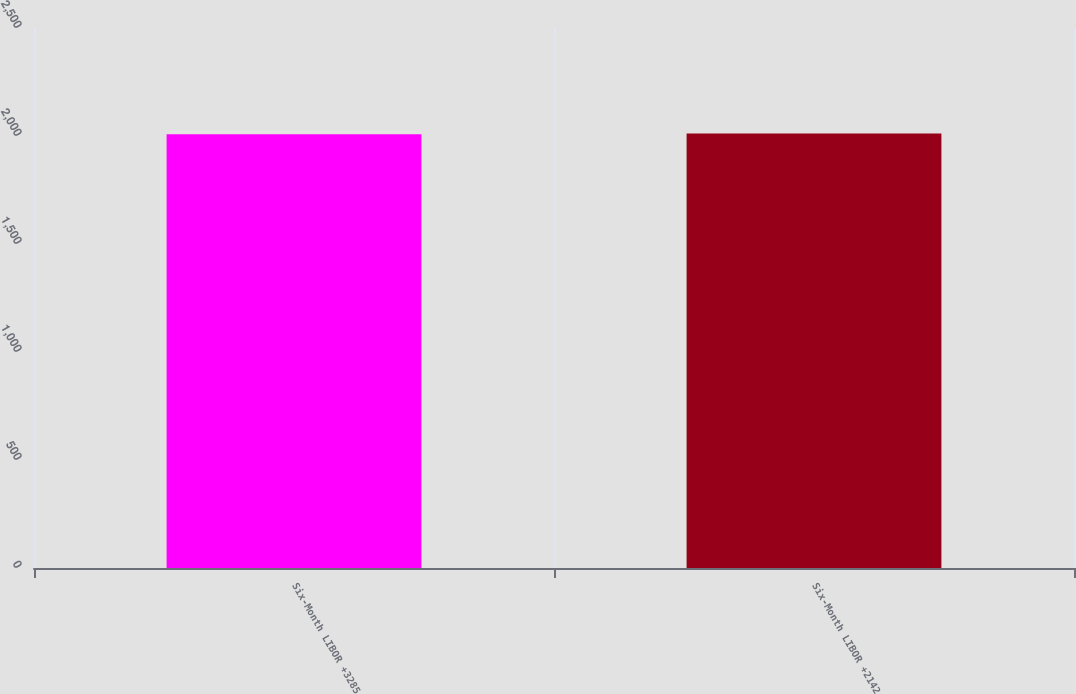<chart> <loc_0><loc_0><loc_500><loc_500><bar_chart><fcel>Six-Month LIBOR +3285<fcel>Six-Month LIBOR +2142<nl><fcel>2008<fcel>2012<nl></chart> 